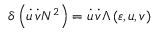<formula> <loc_0><loc_0><loc_500><loc_500>\delta \left ( \dot { u } \, \dot { v } N ^ { 2 } \right ) = \dot { u } \, \dot { v } \Lambda \left ( \varepsilon , u , v \right )</formula> 